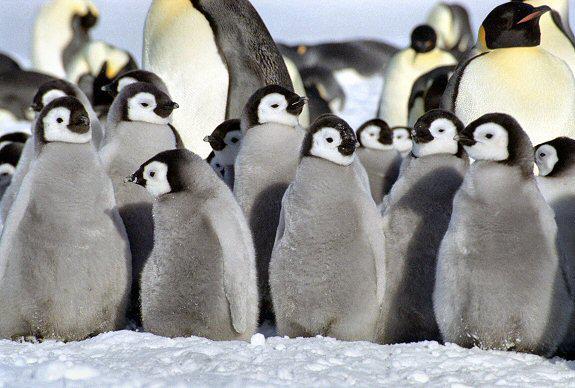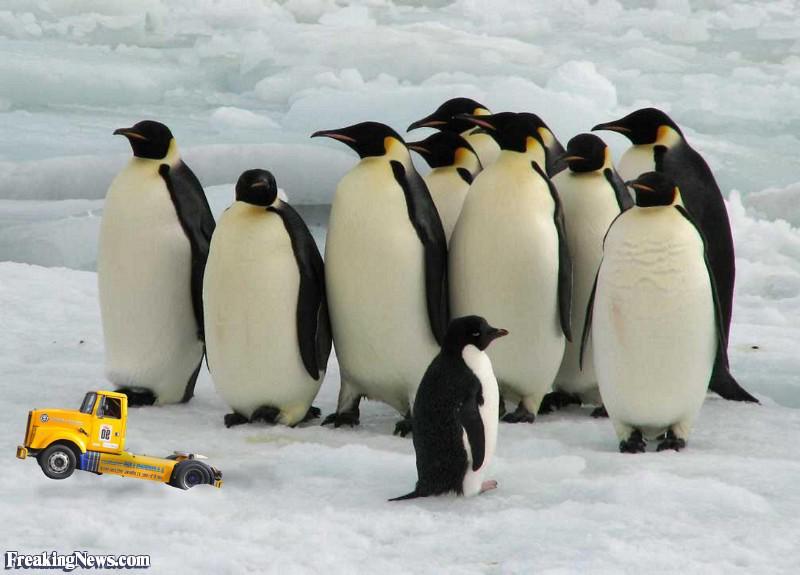The first image is the image on the left, the second image is the image on the right. Assess this claim about the two images: "1 of the penguins has brown fuzz on it.". Correct or not? Answer yes or no. No. 